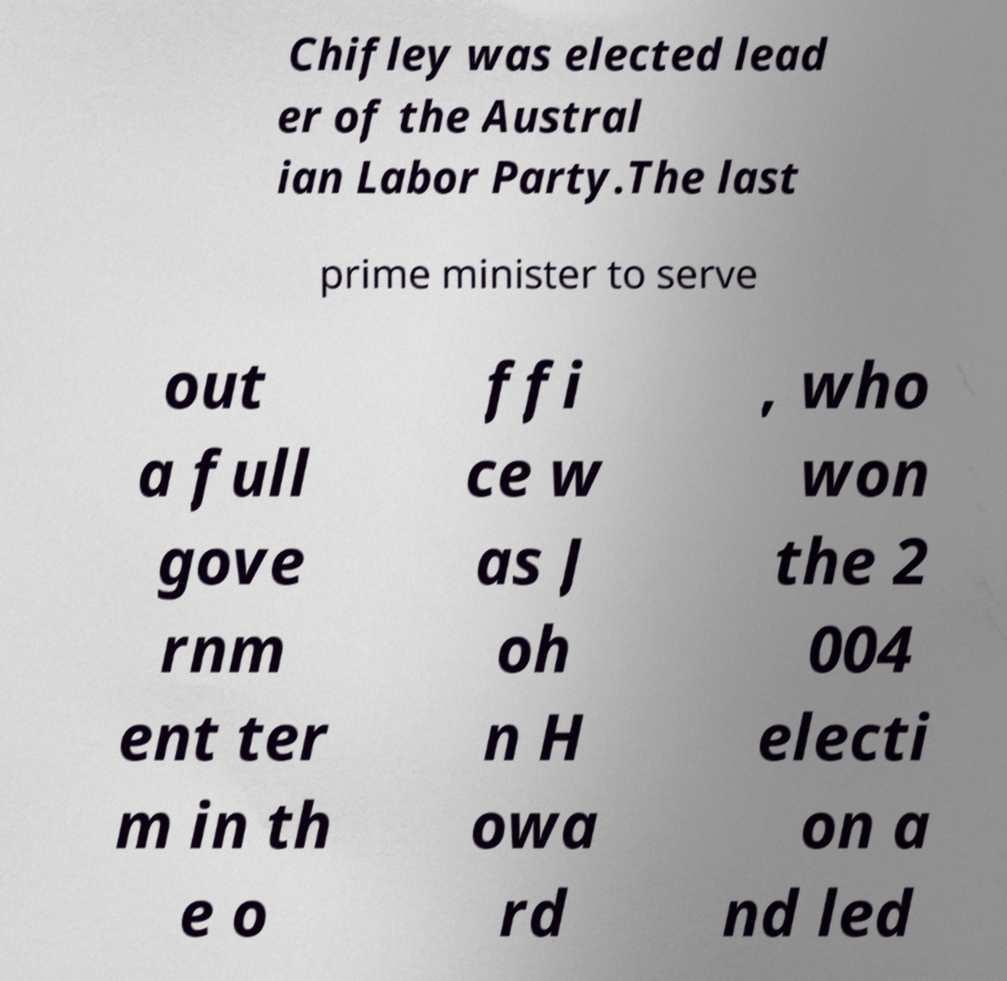Please read and relay the text visible in this image. What does it say? Chifley was elected lead er of the Austral ian Labor Party.The last prime minister to serve out a full gove rnm ent ter m in th e o ffi ce w as J oh n H owa rd , who won the 2 004 electi on a nd led 